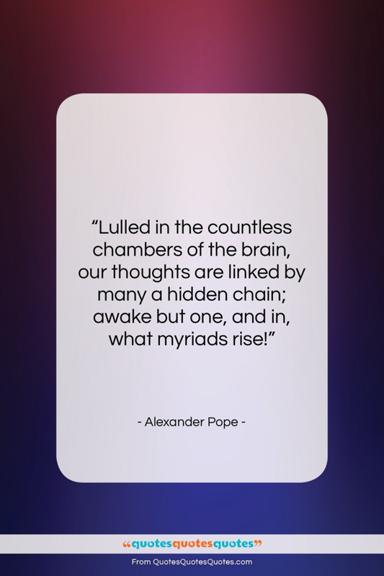What does the quote by Alexander Pope mean?
 The quote by Alexander Pope, "Lulled in the countless chambers of the brain, our thoughts are linked by many a hidden chain awake but one, and in, what myriads rise" is a poetic description of how the human mind works. This quote emphasizes the intricacy and interconnected nature of our thoughts. Each thought is connected by a "hidden chain," and when one thought is awakened, numerous related thoughts can simultaneously arise. The quote celebrates the complexity and depth of our cognitive processes and encourages a sense of wonder at the human mind. What is the color scheme of the image? The image has a white square on a blue background. 